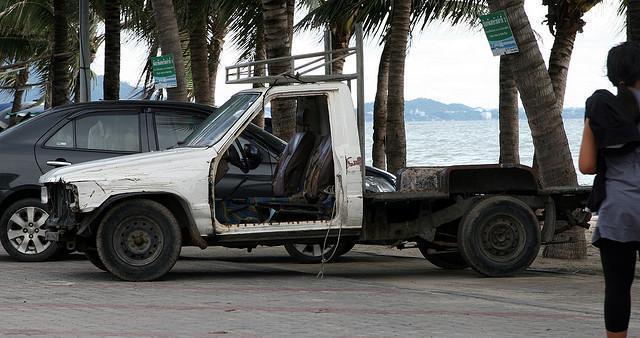What is the truck missing that would make it illegal in many countries?
Indicate the correct response by choosing from the four available options to answer the question.
Options: Truck bed, tires, tail gate, doors. Doors. 